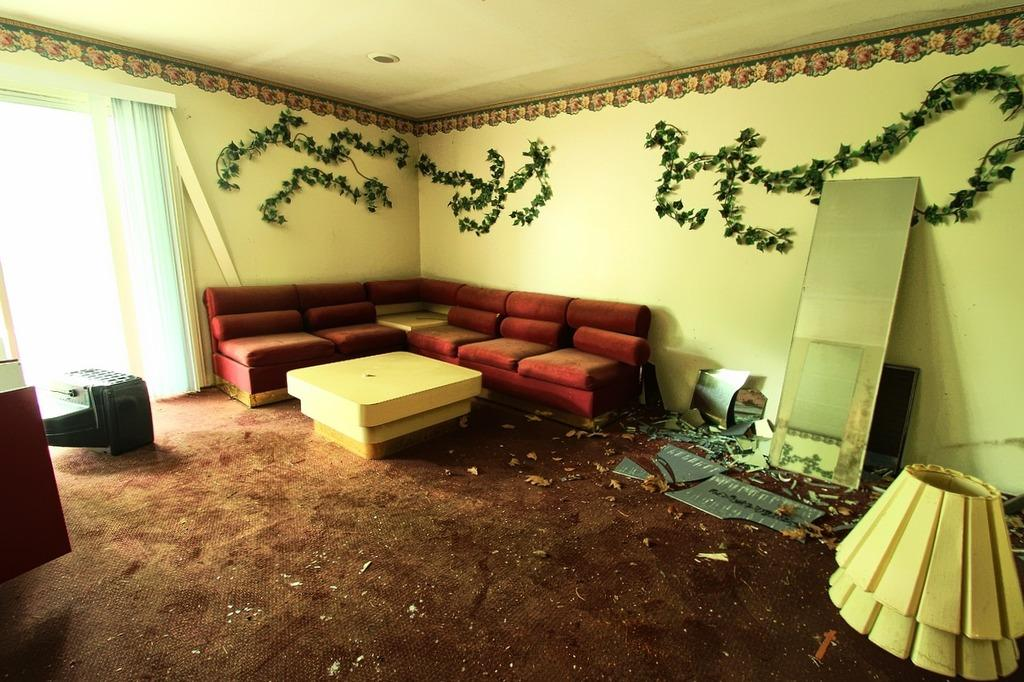What is the color of the wall in the image? The wall in the image is yellow. What can be seen on the wall in the image? There is a window in the image. What type of furniture is present in the image? There are red color sofas in the image. What is located on the right side of the image? There is a lamp on the right side of the image. What type of government is depicted in the image? There is no depiction of a government in the image; it features a yellow wall, a window, red sofas, and a lamp. Can you see any animals in the image? There are no animals present in the image; it does not depict a zoo or any other setting with animals. 